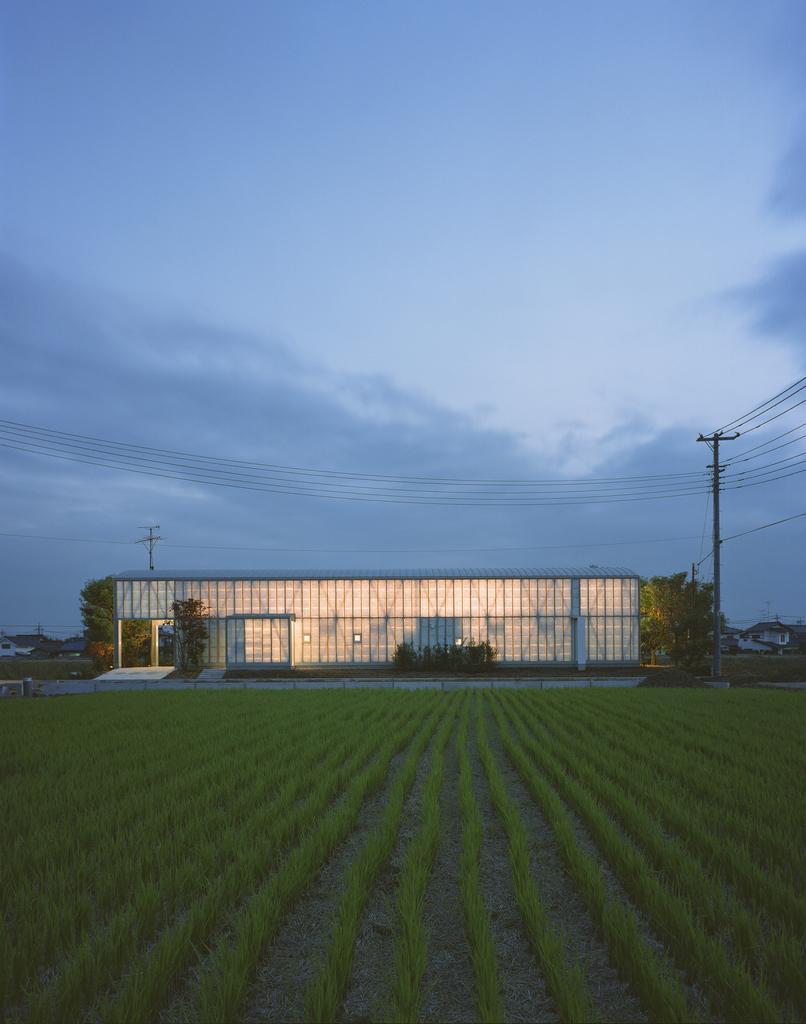Can you describe this image briefly? In the image there is a field with crops and in the front there is a large compartment, beside that there is a pole and many wires are attached to that pole. 